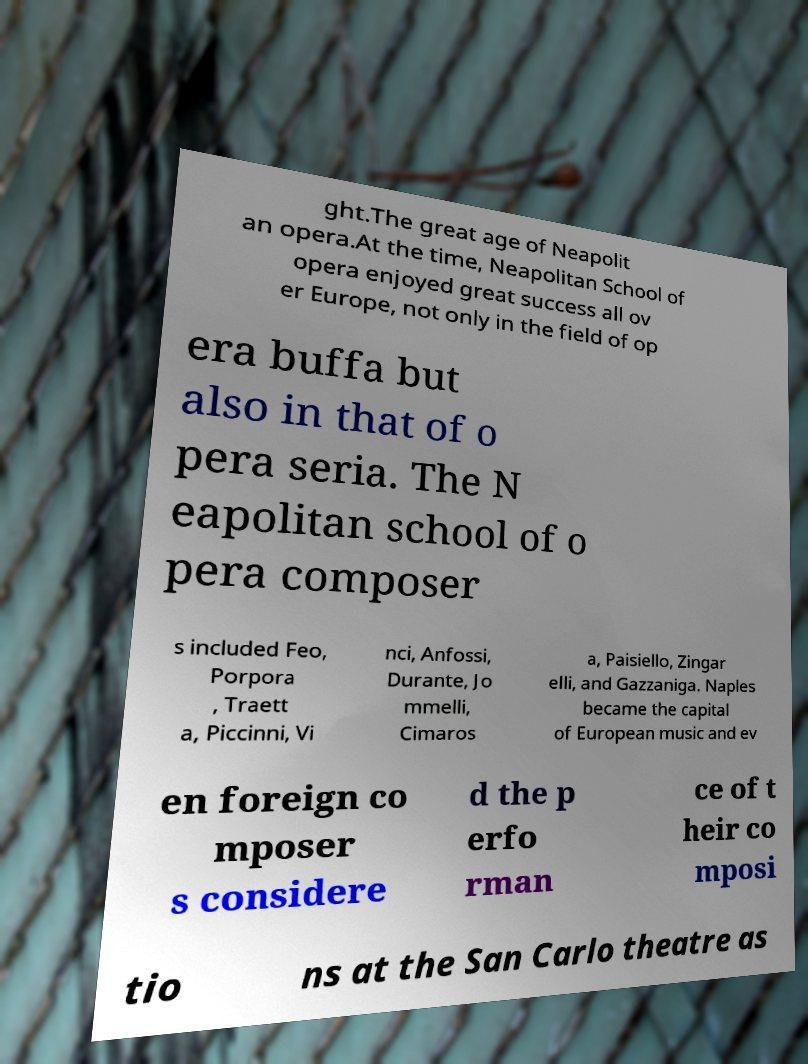Could you assist in decoding the text presented in this image and type it out clearly? ght.The great age of Neapolit an opera.At the time, Neapolitan School of opera enjoyed great success all ov er Europe, not only in the field of op era buffa but also in that of o pera seria. The N eapolitan school of o pera composer s included Feo, Porpora , Traett a, Piccinni, Vi nci, Anfossi, Durante, Jo mmelli, Cimaros a, Paisiello, Zingar elli, and Gazzaniga. Naples became the capital of European music and ev en foreign co mposer s considere d the p erfo rman ce of t heir co mposi tio ns at the San Carlo theatre as 